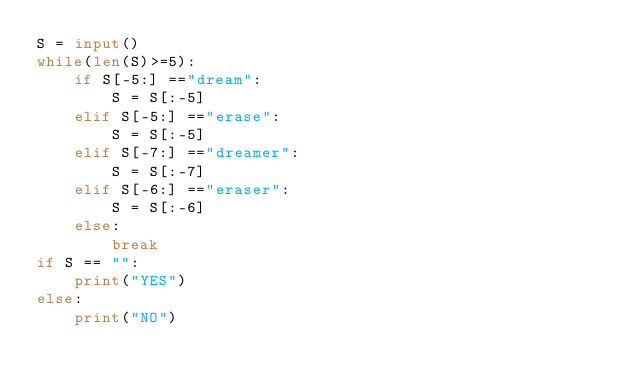<code> <loc_0><loc_0><loc_500><loc_500><_Python_>S = input()
while(len(S)>=5):
    if S[-5:] =="dream":
        S = S[:-5]
    elif S[-5:] =="erase":
        S = S[:-5]
    elif S[-7:] =="dreamer":
        S = S[:-7]
    elif S[-6:] =="eraser":
        S = S[:-6]
    else:
        break
if S == "":
    print("YES")
else:
    print("NO")</code> 